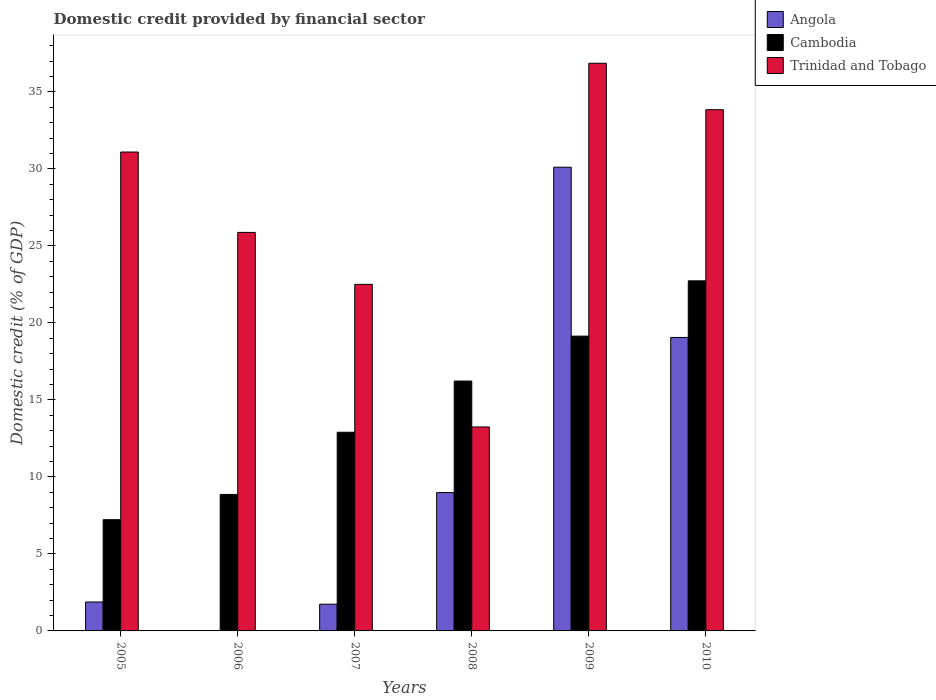How many groups of bars are there?
Your answer should be compact. 6. What is the label of the 3rd group of bars from the left?
Keep it short and to the point. 2007. What is the domestic credit in Angola in 2009?
Provide a succinct answer. 30.12. Across all years, what is the maximum domestic credit in Trinidad and Tobago?
Offer a very short reply. 36.87. Across all years, what is the minimum domestic credit in Cambodia?
Your response must be concise. 7.22. In which year was the domestic credit in Trinidad and Tobago maximum?
Provide a succinct answer. 2009. What is the total domestic credit in Angola in the graph?
Offer a very short reply. 61.77. What is the difference between the domestic credit in Angola in 2009 and that in 2010?
Give a very brief answer. 11.06. What is the difference between the domestic credit in Angola in 2007 and the domestic credit in Cambodia in 2009?
Ensure brevity in your answer.  -17.41. What is the average domestic credit in Cambodia per year?
Give a very brief answer. 14.52. In the year 2005, what is the difference between the domestic credit in Trinidad and Tobago and domestic credit in Cambodia?
Keep it short and to the point. 23.88. What is the ratio of the domestic credit in Angola in 2005 to that in 2007?
Keep it short and to the point. 1.08. What is the difference between the highest and the second highest domestic credit in Trinidad and Tobago?
Ensure brevity in your answer.  3.02. What is the difference between the highest and the lowest domestic credit in Angola?
Your answer should be compact. 30.12. In how many years, is the domestic credit in Cambodia greater than the average domestic credit in Cambodia taken over all years?
Make the answer very short. 3. Is the sum of the domestic credit in Cambodia in 2006 and 2010 greater than the maximum domestic credit in Trinidad and Tobago across all years?
Offer a very short reply. No. How many bars are there?
Offer a terse response. 17. Does the graph contain any zero values?
Make the answer very short. Yes. Where does the legend appear in the graph?
Offer a terse response. Top right. How many legend labels are there?
Keep it short and to the point. 3. How are the legend labels stacked?
Ensure brevity in your answer.  Vertical. What is the title of the graph?
Offer a terse response. Domestic credit provided by financial sector. What is the label or title of the X-axis?
Provide a succinct answer. Years. What is the label or title of the Y-axis?
Provide a short and direct response. Domestic credit (% of GDP). What is the Domestic credit (% of GDP) of Angola in 2005?
Provide a short and direct response. 1.88. What is the Domestic credit (% of GDP) of Cambodia in 2005?
Keep it short and to the point. 7.22. What is the Domestic credit (% of GDP) of Trinidad and Tobago in 2005?
Keep it short and to the point. 31.1. What is the Domestic credit (% of GDP) of Cambodia in 2006?
Your response must be concise. 8.86. What is the Domestic credit (% of GDP) of Trinidad and Tobago in 2006?
Your answer should be very brief. 25.88. What is the Domestic credit (% of GDP) in Angola in 2007?
Your answer should be compact. 1.74. What is the Domestic credit (% of GDP) of Cambodia in 2007?
Your answer should be compact. 12.9. What is the Domestic credit (% of GDP) in Trinidad and Tobago in 2007?
Make the answer very short. 22.51. What is the Domestic credit (% of GDP) in Angola in 2008?
Make the answer very short. 8.98. What is the Domestic credit (% of GDP) of Cambodia in 2008?
Keep it short and to the point. 16.23. What is the Domestic credit (% of GDP) of Trinidad and Tobago in 2008?
Offer a terse response. 13.25. What is the Domestic credit (% of GDP) in Angola in 2009?
Provide a succinct answer. 30.12. What is the Domestic credit (% of GDP) of Cambodia in 2009?
Offer a terse response. 19.14. What is the Domestic credit (% of GDP) of Trinidad and Tobago in 2009?
Make the answer very short. 36.87. What is the Domestic credit (% of GDP) in Angola in 2010?
Offer a terse response. 19.06. What is the Domestic credit (% of GDP) in Cambodia in 2010?
Provide a succinct answer. 22.74. What is the Domestic credit (% of GDP) in Trinidad and Tobago in 2010?
Your answer should be very brief. 33.85. Across all years, what is the maximum Domestic credit (% of GDP) in Angola?
Your answer should be compact. 30.12. Across all years, what is the maximum Domestic credit (% of GDP) of Cambodia?
Provide a succinct answer. 22.74. Across all years, what is the maximum Domestic credit (% of GDP) of Trinidad and Tobago?
Give a very brief answer. 36.87. Across all years, what is the minimum Domestic credit (% of GDP) in Cambodia?
Give a very brief answer. 7.22. Across all years, what is the minimum Domestic credit (% of GDP) in Trinidad and Tobago?
Your response must be concise. 13.25. What is the total Domestic credit (% of GDP) in Angola in the graph?
Your answer should be compact. 61.77. What is the total Domestic credit (% of GDP) of Cambodia in the graph?
Offer a terse response. 87.1. What is the total Domestic credit (% of GDP) in Trinidad and Tobago in the graph?
Your answer should be compact. 163.45. What is the difference between the Domestic credit (% of GDP) in Cambodia in 2005 and that in 2006?
Provide a short and direct response. -1.64. What is the difference between the Domestic credit (% of GDP) in Trinidad and Tobago in 2005 and that in 2006?
Provide a succinct answer. 5.22. What is the difference between the Domestic credit (% of GDP) in Angola in 2005 and that in 2007?
Keep it short and to the point. 0.14. What is the difference between the Domestic credit (% of GDP) of Cambodia in 2005 and that in 2007?
Offer a very short reply. -5.68. What is the difference between the Domestic credit (% of GDP) of Trinidad and Tobago in 2005 and that in 2007?
Your answer should be very brief. 8.59. What is the difference between the Domestic credit (% of GDP) of Angola in 2005 and that in 2008?
Give a very brief answer. -7.11. What is the difference between the Domestic credit (% of GDP) in Cambodia in 2005 and that in 2008?
Ensure brevity in your answer.  -9. What is the difference between the Domestic credit (% of GDP) of Trinidad and Tobago in 2005 and that in 2008?
Your answer should be compact. 17.86. What is the difference between the Domestic credit (% of GDP) of Angola in 2005 and that in 2009?
Offer a terse response. -28.24. What is the difference between the Domestic credit (% of GDP) of Cambodia in 2005 and that in 2009?
Offer a terse response. -11.92. What is the difference between the Domestic credit (% of GDP) in Trinidad and Tobago in 2005 and that in 2009?
Your response must be concise. -5.76. What is the difference between the Domestic credit (% of GDP) of Angola in 2005 and that in 2010?
Keep it short and to the point. -17.18. What is the difference between the Domestic credit (% of GDP) of Cambodia in 2005 and that in 2010?
Your response must be concise. -15.51. What is the difference between the Domestic credit (% of GDP) in Trinidad and Tobago in 2005 and that in 2010?
Ensure brevity in your answer.  -2.75. What is the difference between the Domestic credit (% of GDP) in Cambodia in 2006 and that in 2007?
Provide a succinct answer. -4.04. What is the difference between the Domestic credit (% of GDP) of Trinidad and Tobago in 2006 and that in 2007?
Make the answer very short. 3.37. What is the difference between the Domestic credit (% of GDP) in Cambodia in 2006 and that in 2008?
Your answer should be very brief. -7.36. What is the difference between the Domestic credit (% of GDP) of Trinidad and Tobago in 2006 and that in 2008?
Offer a terse response. 12.63. What is the difference between the Domestic credit (% of GDP) in Cambodia in 2006 and that in 2009?
Give a very brief answer. -10.28. What is the difference between the Domestic credit (% of GDP) in Trinidad and Tobago in 2006 and that in 2009?
Keep it short and to the point. -10.98. What is the difference between the Domestic credit (% of GDP) in Cambodia in 2006 and that in 2010?
Offer a very short reply. -13.87. What is the difference between the Domestic credit (% of GDP) of Trinidad and Tobago in 2006 and that in 2010?
Provide a succinct answer. -7.97. What is the difference between the Domestic credit (% of GDP) of Angola in 2007 and that in 2008?
Offer a very short reply. -7.25. What is the difference between the Domestic credit (% of GDP) in Cambodia in 2007 and that in 2008?
Give a very brief answer. -3.33. What is the difference between the Domestic credit (% of GDP) in Trinidad and Tobago in 2007 and that in 2008?
Make the answer very short. 9.26. What is the difference between the Domestic credit (% of GDP) of Angola in 2007 and that in 2009?
Provide a succinct answer. -28.38. What is the difference between the Domestic credit (% of GDP) of Cambodia in 2007 and that in 2009?
Offer a terse response. -6.24. What is the difference between the Domestic credit (% of GDP) of Trinidad and Tobago in 2007 and that in 2009?
Provide a short and direct response. -14.36. What is the difference between the Domestic credit (% of GDP) in Angola in 2007 and that in 2010?
Ensure brevity in your answer.  -17.32. What is the difference between the Domestic credit (% of GDP) of Cambodia in 2007 and that in 2010?
Provide a short and direct response. -9.83. What is the difference between the Domestic credit (% of GDP) in Trinidad and Tobago in 2007 and that in 2010?
Give a very brief answer. -11.34. What is the difference between the Domestic credit (% of GDP) of Angola in 2008 and that in 2009?
Provide a succinct answer. -21.13. What is the difference between the Domestic credit (% of GDP) in Cambodia in 2008 and that in 2009?
Offer a very short reply. -2.92. What is the difference between the Domestic credit (% of GDP) of Trinidad and Tobago in 2008 and that in 2009?
Provide a short and direct response. -23.62. What is the difference between the Domestic credit (% of GDP) in Angola in 2008 and that in 2010?
Offer a terse response. -10.07. What is the difference between the Domestic credit (% of GDP) of Cambodia in 2008 and that in 2010?
Your answer should be very brief. -6.51. What is the difference between the Domestic credit (% of GDP) in Trinidad and Tobago in 2008 and that in 2010?
Give a very brief answer. -20.6. What is the difference between the Domestic credit (% of GDP) in Angola in 2009 and that in 2010?
Give a very brief answer. 11.06. What is the difference between the Domestic credit (% of GDP) in Cambodia in 2009 and that in 2010?
Keep it short and to the point. -3.59. What is the difference between the Domestic credit (% of GDP) in Trinidad and Tobago in 2009 and that in 2010?
Your response must be concise. 3.02. What is the difference between the Domestic credit (% of GDP) in Angola in 2005 and the Domestic credit (% of GDP) in Cambodia in 2006?
Provide a succinct answer. -6.98. What is the difference between the Domestic credit (% of GDP) in Angola in 2005 and the Domestic credit (% of GDP) in Trinidad and Tobago in 2006?
Make the answer very short. -24. What is the difference between the Domestic credit (% of GDP) in Cambodia in 2005 and the Domestic credit (% of GDP) in Trinidad and Tobago in 2006?
Ensure brevity in your answer.  -18.66. What is the difference between the Domestic credit (% of GDP) of Angola in 2005 and the Domestic credit (% of GDP) of Cambodia in 2007?
Offer a very short reply. -11.02. What is the difference between the Domestic credit (% of GDP) in Angola in 2005 and the Domestic credit (% of GDP) in Trinidad and Tobago in 2007?
Keep it short and to the point. -20.63. What is the difference between the Domestic credit (% of GDP) of Cambodia in 2005 and the Domestic credit (% of GDP) of Trinidad and Tobago in 2007?
Offer a terse response. -15.28. What is the difference between the Domestic credit (% of GDP) in Angola in 2005 and the Domestic credit (% of GDP) in Cambodia in 2008?
Give a very brief answer. -14.35. What is the difference between the Domestic credit (% of GDP) in Angola in 2005 and the Domestic credit (% of GDP) in Trinidad and Tobago in 2008?
Your response must be concise. -11.37. What is the difference between the Domestic credit (% of GDP) of Cambodia in 2005 and the Domestic credit (% of GDP) of Trinidad and Tobago in 2008?
Ensure brevity in your answer.  -6.02. What is the difference between the Domestic credit (% of GDP) in Angola in 2005 and the Domestic credit (% of GDP) in Cambodia in 2009?
Ensure brevity in your answer.  -17.27. What is the difference between the Domestic credit (% of GDP) of Angola in 2005 and the Domestic credit (% of GDP) of Trinidad and Tobago in 2009?
Make the answer very short. -34.99. What is the difference between the Domestic credit (% of GDP) of Cambodia in 2005 and the Domestic credit (% of GDP) of Trinidad and Tobago in 2009?
Offer a terse response. -29.64. What is the difference between the Domestic credit (% of GDP) in Angola in 2005 and the Domestic credit (% of GDP) in Cambodia in 2010?
Keep it short and to the point. -20.86. What is the difference between the Domestic credit (% of GDP) in Angola in 2005 and the Domestic credit (% of GDP) in Trinidad and Tobago in 2010?
Offer a very short reply. -31.97. What is the difference between the Domestic credit (% of GDP) in Cambodia in 2005 and the Domestic credit (% of GDP) in Trinidad and Tobago in 2010?
Your answer should be very brief. -26.62. What is the difference between the Domestic credit (% of GDP) of Cambodia in 2006 and the Domestic credit (% of GDP) of Trinidad and Tobago in 2007?
Keep it short and to the point. -13.64. What is the difference between the Domestic credit (% of GDP) of Cambodia in 2006 and the Domestic credit (% of GDP) of Trinidad and Tobago in 2008?
Your answer should be compact. -4.38. What is the difference between the Domestic credit (% of GDP) in Cambodia in 2006 and the Domestic credit (% of GDP) in Trinidad and Tobago in 2009?
Make the answer very short. -28. What is the difference between the Domestic credit (% of GDP) of Cambodia in 2006 and the Domestic credit (% of GDP) of Trinidad and Tobago in 2010?
Provide a succinct answer. -24.98. What is the difference between the Domestic credit (% of GDP) of Angola in 2007 and the Domestic credit (% of GDP) of Cambodia in 2008?
Your response must be concise. -14.49. What is the difference between the Domestic credit (% of GDP) of Angola in 2007 and the Domestic credit (% of GDP) of Trinidad and Tobago in 2008?
Give a very brief answer. -11.51. What is the difference between the Domestic credit (% of GDP) of Cambodia in 2007 and the Domestic credit (% of GDP) of Trinidad and Tobago in 2008?
Offer a very short reply. -0.34. What is the difference between the Domestic credit (% of GDP) of Angola in 2007 and the Domestic credit (% of GDP) of Cambodia in 2009?
Your response must be concise. -17.41. What is the difference between the Domestic credit (% of GDP) in Angola in 2007 and the Domestic credit (% of GDP) in Trinidad and Tobago in 2009?
Keep it short and to the point. -35.13. What is the difference between the Domestic credit (% of GDP) of Cambodia in 2007 and the Domestic credit (% of GDP) of Trinidad and Tobago in 2009?
Offer a terse response. -23.96. What is the difference between the Domestic credit (% of GDP) in Angola in 2007 and the Domestic credit (% of GDP) in Cambodia in 2010?
Provide a short and direct response. -21. What is the difference between the Domestic credit (% of GDP) of Angola in 2007 and the Domestic credit (% of GDP) of Trinidad and Tobago in 2010?
Ensure brevity in your answer.  -32.11. What is the difference between the Domestic credit (% of GDP) in Cambodia in 2007 and the Domestic credit (% of GDP) in Trinidad and Tobago in 2010?
Ensure brevity in your answer.  -20.95. What is the difference between the Domestic credit (% of GDP) of Angola in 2008 and the Domestic credit (% of GDP) of Cambodia in 2009?
Provide a succinct answer. -10.16. What is the difference between the Domestic credit (% of GDP) in Angola in 2008 and the Domestic credit (% of GDP) in Trinidad and Tobago in 2009?
Your response must be concise. -27.88. What is the difference between the Domestic credit (% of GDP) of Cambodia in 2008 and the Domestic credit (% of GDP) of Trinidad and Tobago in 2009?
Provide a succinct answer. -20.64. What is the difference between the Domestic credit (% of GDP) in Angola in 2008 and the Domestic credit (% of GDP) in Cambodia in 2010?
Offer a very short reply. -13.75. What is the difference between the Domestic credit (% of GDP) in Angola in 2008 and the Domestic credit (% of GDP) in Trinidad and Tobago in 2010?
Keep it short and to the point. -24.86. What is the difference between the Domestic credit (% of GDP) of Cambodia in 2008 and the Domestic credit (% of GDP) of Trinidad and Tobago in 2010?
Provide a short and direct response. -17.62. What is the difference between the Domestic credit (% of GDP) of Angola in 2009 and the Domestic credit (% of GDP) of Cambodia in 2010?
Your response must be concise. 7.38. What is the difference between the Domestic credit (% of GDP) of Angola in 2009 and the Domestic credit (% of GDP) of Trinidad and Tobago in 2010?
Ensure brevity in your answer.  -3.73. What is the difference between the Domestic credit (% of GDP) in Cambodia in 2009 and the Domestic credit (% of GDP) in Trinidad and Tobago in 2010?
Keep it short and to the point. -14.7. What is the average Domestic credit (% of GDP) in Angola per year?
Your answer should be very brief. 10.3. What is the average Domestic credit (% of GDP) of Cambodia per year?
Keep it short and to the point. 14.52. What is the average Domestic credit (% of GDP) of Trinidad and Tobago per year?
Offer a terse response. 27.24. In the year 2005, what is the difference between the Domestic credit (% of GDP) in Angola and Domestic credit (% of GDP) in Cambodia?
Your answer should be very brief. -5.34. In the year 2005, what is the difference between the Domestic credit (% of GDP) in Angola and Domestic credit (% of GDP) in Trinidad and Tobago?
Give a very brief answer. -29.22. In the year 2005, what is the difference between the Domestic credit (% of GDP) in Cambodia and Domestic credit (% of GDP) in Trinidad and Tobago?
Keep it short and to the point. -23.88. In the year 2006, what is the difference between the Domestic credit (% of GDP) of Cambodia and Domestic credit (% of GDP) of Trinidad and Tobago?
Provide a short and direct response. -17.02. In the year 2007, what is the difference between the Domestic credit (% of GDP) of Angola and Domestic credit (% of GDP) of Cambodia?
Your answer should be compact. -11.17. In the year 2007, what is the difference between the Domestic credit (% of GDP) in Angola and Domestic credit (% of GDP) in Trinidad and Tobago?
Make the answer very short. -20.77. In the year 2007, what is the difference between the Domestic credit (% of GDP) in Cambodia and Domestic credit (% of GDP) in Trinidad and Tobago?
Offer a terse response. -9.61. In the year 2008, what is the difference between the Domestic credit (% of GDP) of Angola and Domestic credit (% of GDP) of Cambodia?
Your answer should be compact. -7.24. In the year 2008, what is the difference between the Domestic credit (% of GDP) of Angola and Domestic credit (% of GDP) of Trinidad and Tobago?
Offer a terse response. -4.26. In the year 2008, what is the difference between the Domestic credit (% of GDP) of Cambodia and Domestic credit (% of GDP) of Trinidad and Tobago?
Provide a succinct answer. 2.98. In the year 2009, what is the difference between the Domestic credit (% of GDP) of Angola and Domestic credit (% of GDP) of Cambodia?
Provide a succinct answer. 10.97. In the year 2009, what is the difference between the Domestic credit (% of GDP) of Angola and Domestic credit (% of GDP) of Trinidad and Tobago?
Make the answer very short. -6.75. In the year 2009, what is the difference between the Domestic credit (% of GDP) in Cambodia and Domestic credit (% of GDP) in Trinidad and Tobago?
Offer a very short reply. -17.72. In the year 2010, what is the difference between the Domestic credit (% of GDP) in Angola and Domestic credit (% of GDP) in Cambodia?
Ensure brevity in your answer.  -3.68. In the year 2010, what is the difference between the Domestic credit (% of GDP) of Angola and Domestic credit (% of GDP) of Trinidad and Tobago?
Your answer should be very brief. -14.79. In the year 2010, what is the difference between the Domestic credit (% of GDP) in Cambodia and Domestic credit (% of GDP) in Trinidad and Tobago?
Offer a terse response. -11.11. What is the ratio of the Domestic credit (% of GDP) of Cambodia in 2005 to that in 2006?
Your response must be concise. 0.81. What is the ratio of the Domestic credit (% of GDP) of Trinidad and Tobago in 2005 to that in 2006?
Your response must be concise. 1.2. What is the ratio of the Domestic credit (% of GDP) of Angola in 2005 to that in 2007?
Offer a very short reply. 1.08. What is the ratio of the Domestic credit (% of GDP) in Cambodia in 2005 to that in 2007?
Keep it short and to the point. 0.56. What is the ratio of the Domestic credit (% of GDP) in Trinidad and Tobago in 2005 to that in 2007?
Provide a short and direct response. 1.38. What is the ratio of the Domestic credit (% of GDP) in Angola in 2005 to that in 2008?
Keep it short and to the point. 0.21. What is the ratio of the Domestic credit (% of GDP) in Cambodia in 2005 to that in 2008?
Provide a succinct answer. 0.45. What is the ratio of the Domestic credit (% of GDP) of Trinidad and Tobago in 2005 to that in 2008?
Give a very brief answer. 2.35. What is the ratio of the Domestic credit (% of GDP) in Angola in 2005 to that in 2009?
Ensure brevity in your answer.  0.06. What is the ratio of the Domestic credit (% of GDP) in Cambodia in 2005 to that in 2009?
Keep it short and to the point. 0.38. What is the ratio of the Domestic credit (% of GDP) of Trinidad and Tobago in 2005 to that in 2009?
Your response must be concise. 0.84. What is the ratio of the Domestic credit (% of GDP) in Angola in 2005 to that in 2010?
Your answer should be compact. 0.1. What is the ratio of the Domestic credit (% of GDP) in Cambodia in 2005 to that in 2010?
Provide a succinct answer. 0.32. What is the ratio of the Domestic credit (% of GDP) in Trinidad and Tobago in 2005 to that in 2010?
Provide a short and direct response. 0.92. What is the ratio of the Domestic credit (% of GDP) in Cambodia in 2006 to that in 2007?
Give a very brief answer. 0.69. What is the ratio of the Domestic credit (% of GDP) in Trinidad and Tobago in 2006 to that in 2007?
Make the answer very short. 1.15. What is the ratio of the Domestic credit (% of GDP) of Cambodia in 2006 to that in 2008?
Provide a succinct answer. 0.55. What is the ratio of the Domestic credit (% of GDP) of Trinidad and Tobago in 2006 to that in 2008?
Keep it short and to the point. 1.95. What is the ratio of the Domestic credit (% of GDP) in Cambodia in 2006 to that in 2009?
Your answer should be compact. 0.46. What is the ratio of the Domestic credit (% of GDP) in Trinidad and Tobago in 2006 to that in 2009?
Give a very brief answer. 0.7. What is the ratio of the Domestic credit (% of GDP) of Cambodia in 2006 to that in 2010?
Your answer should be very brief. 0.39. What is the ratio of the Domestic credit (% of GDP) of Trinidad and Tobago in 2006 to that in 2010?
Give a very brief answer. 0.76. What is the ratio of the Domestic credit (% of GDP) of Angola in 2007 to that in 2008?
Provide a succinct answer. 0.19. What is the ratio of the Domestic credit (% of GDP) in Cambodia in 2007 to that in 2008?
Your answer should be compact. 0.8. What is the ratio of the Domestic credit (% of GDP) in Trinidad and Tobago in 2007 to that in 2008?
Your answer should be very brief. 1.7. What is the ratio of the Domestic credit (% of GDP) of Angola in 2007 to that in 2009?
Offer a terse response. 0.06. What is the ratio of the Domestic credit (% of GDP) in Cambodia in 2007 to that in 2009?
Ensure brevity in your answer.  0.67. What is the ratio of the Domestic credit (% of GDP) in Trinidad and Tobago in 2007 to that in 2009?
Keep it short and to the point. 0.61. What is the ratio of the Domestic credit (% of GDP) of Angola in 2007 to that in 2010?
Your answer should be very brief. 0.09. What is the ratio of the Domestic credit (% of GDP) in Cambodia in 2007 to that in 2010?
Give a very brief answer. 0.57. What is the ratio of the Domestic credit (% of GDP) of Trinidad and Tobago in 2007 to that in 2010?
Provide a succinct answer. 0.67. What is the ratio of the Domestic credit (% of GDP) in Angola in 2008 to that in 2009?
Give a very brief answer. 0.3. What is the ratio of the Domestic credit (% of GDP) of Cambodia in 2008 to that in 2009?
Provide a succinct answer. 0.85. What is the ratio of the Domestic credit (% of GDP) of Trinidad and Tobago in 2008 to that in 2009?
Your answer should be compact. 0.36. What is the ratio of the Domestic credit (% of GDP) in Angola in 2008 to that in 2010?
Make the answer very short. 0.47. What is the ratio of the Domestic credit (% of GDP) in Cambodia in 2008 to that in 2010?
Keep it short and to the point. 0.71. What is the ratio of the Domestic credit (% of GDP) of Trinidad and Tobago in 2008 to that in 2010?
Offer a very short reply. 0.39. What is the ratio of the Domestic credit (% of GDP) in Angola in 2009 to that in 2010?
Your answer should be compact. 1.58. What is the ratio of the Domestic credit (% of GDP) in Cambodia in 2009 to that in 2010?
Your answer should be compact. 0.84. What is the ratio of the Domestic credit (% of GDP) of Trinidad and Tobago in 2009 to that in 2010?
Keep it short and to the point. 1.09. What is the difference between the highest and the second highest Domestic credit (% of GDP) of Angola?
Provide a short and direct response. 11.06. What is the difference between the highest and the second highest Domestic credit (% of GDP) in Cambodia?
Provide a succinct answer. 3.59. What is the difference between the highest and the second highest Domestic credit (% of GDP) in Trinidad and Tobago?
Keep it short and to the point. 3.02. What is the difference between the highest and the lowest Domestic credit (% of GDP) in Angola?
Your response must be concise. 30.12. What is the difference between the highest and the lowest Domestic credit (% of GDP) in Cambodia?
Provide a short and direct response. 15.51. What is the difference between the highest and the lowest Domestic credit (% of GDP) in Trinidad and Tobago?
Ensure brevity in your answer.  23.62. 